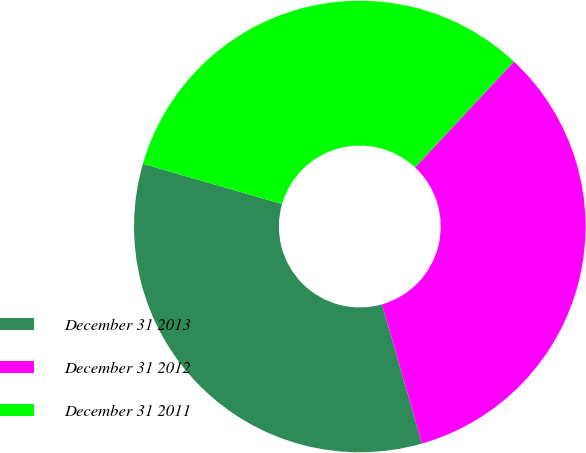Convert chart to OTSL. <chart><loc_0><loc_0><loc_500><loc_500><pie_chart><fcel>December 31 2013<fcel>December 31 2012<fcel>December 31 2011<nl><fcel>33.92%<fcel>33.6%<fcel>32.48%<nl></chart> 